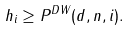Convert formula to latex. <formula><loc_0><loc_0><loc_500><loc_500>h _ { i } \geq P ^ { D W } ( d , n , i ) .</formula> 